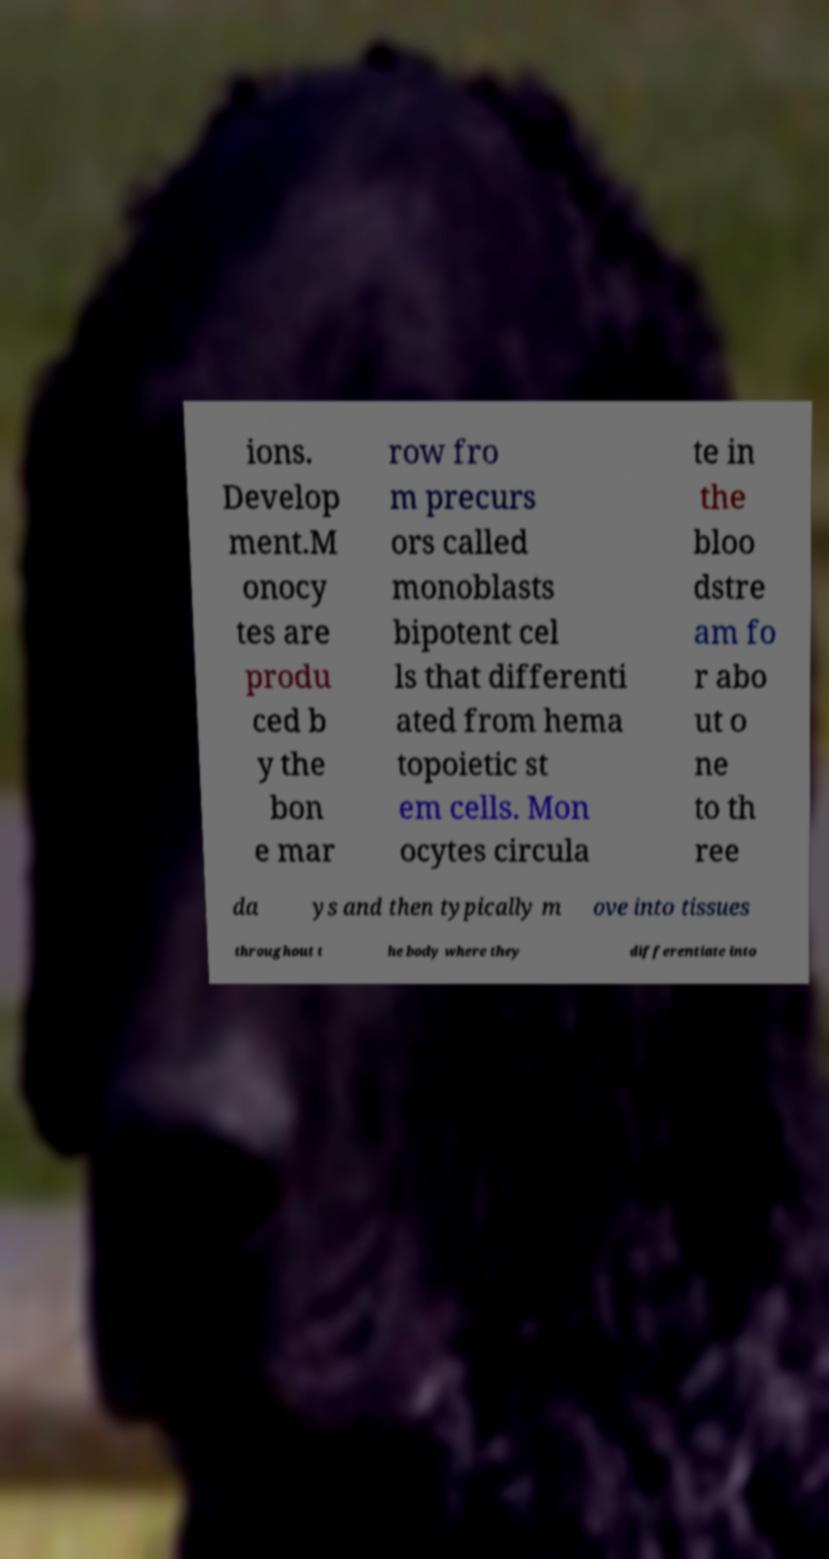For documentation purposes, I need the text within this image transcribed. Could you provide that? ions. Develop ment.M onocy tes are produ ced b y the bon e mar row fro m precurs ors called monoblasts bipotent cel ls that differenti ated from hema topoietic st em cells. Mon ocytes circula te in the bloo dstre am fo r abo ut o ne to th ree da ys and then typically m ove into tissues throughout t he body where they differentiate into 